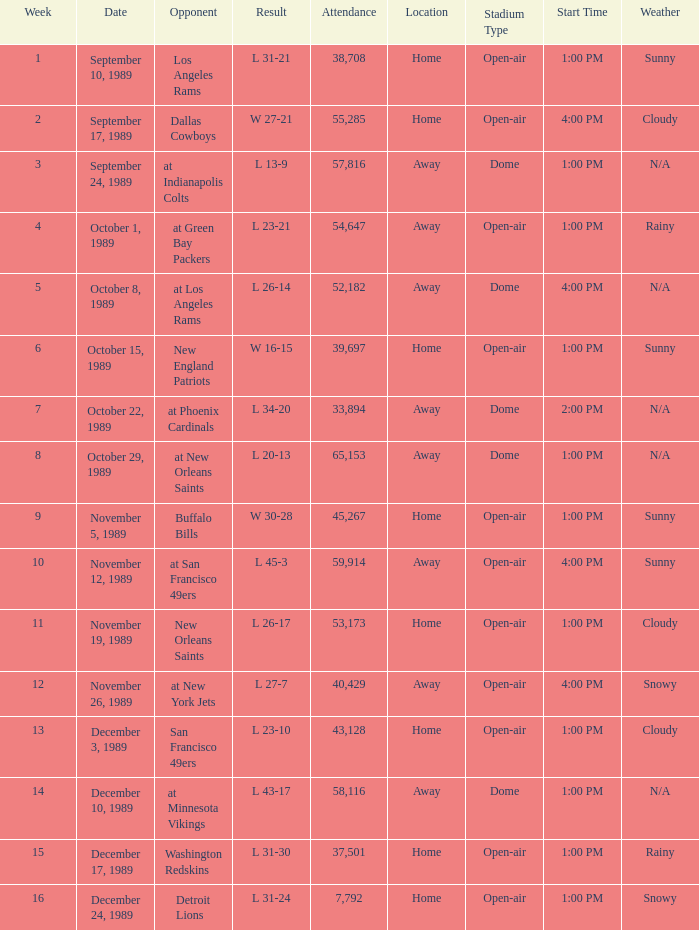During which week was the attendance 40,429? 12.0. 